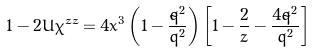<formula> <loc_0><loc_0><loc_500><loc_500>1 - 2 U \chi ^ { z z } = 4 x ^ { 3 } \left ( 1 - \frac { { \tilde { q } } ^ { 2 } } { { \bar { q } } ^ { 2 } } \right ) \left [ 1 - \frac { 2 } { z } - \frac { 4 { \tilde { q } } ^ { 2 } } { { \bar { q } } ^ { 2 } } \right ]</formula> 